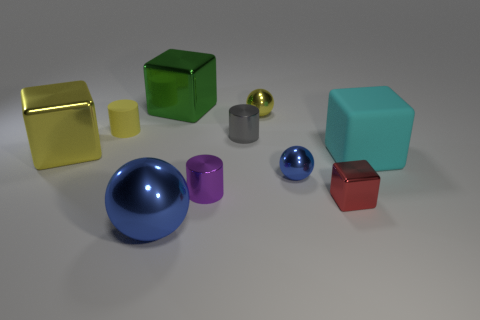What is the shape of the blue shiny thing behind the tiny purple object?
Your answer should be very brief. Sphere. What shape is the blue shiny object to the left of the tiny gray cylinder to the right of the matte thing on the left side of the cyan thing?
Your response must be concise. Sphere. How many things are tiny blue shiny cylinders or large cyan things?
Your answer should be compact. 1. Do the big metallic object on the left side of the small yellow rubber object and the blue object that is to the left of the tiny blue metal object have the same shape?
Your answer should be very brief. No. How many shiny things are on the right side of the tiny purple shiny cylinder and left of the tiny blue ball?
Ensure brevity in your answer.  2. How many other objects are the same size as the yellow ball?
Offer a terse response. 5. There is a small cylinder that is both on the left side of the small gray cylinder and behind the large cyan rubber thing; what is it made of?
Keep it short and to the point. Rubber. There is a tiny matte thing; is it the same color as the object left of the tiny yellow matte cylinder?
Your answer should be compact. Yes. There is a yellow thing that is the same shape as the cyan matte object; what is its size?
Provide a short and direct response. Large. What is the shape of the large thing that is left of the small blue metal object and on the right side of the large shiny ball?
Provide a succinct answer. Cube. 